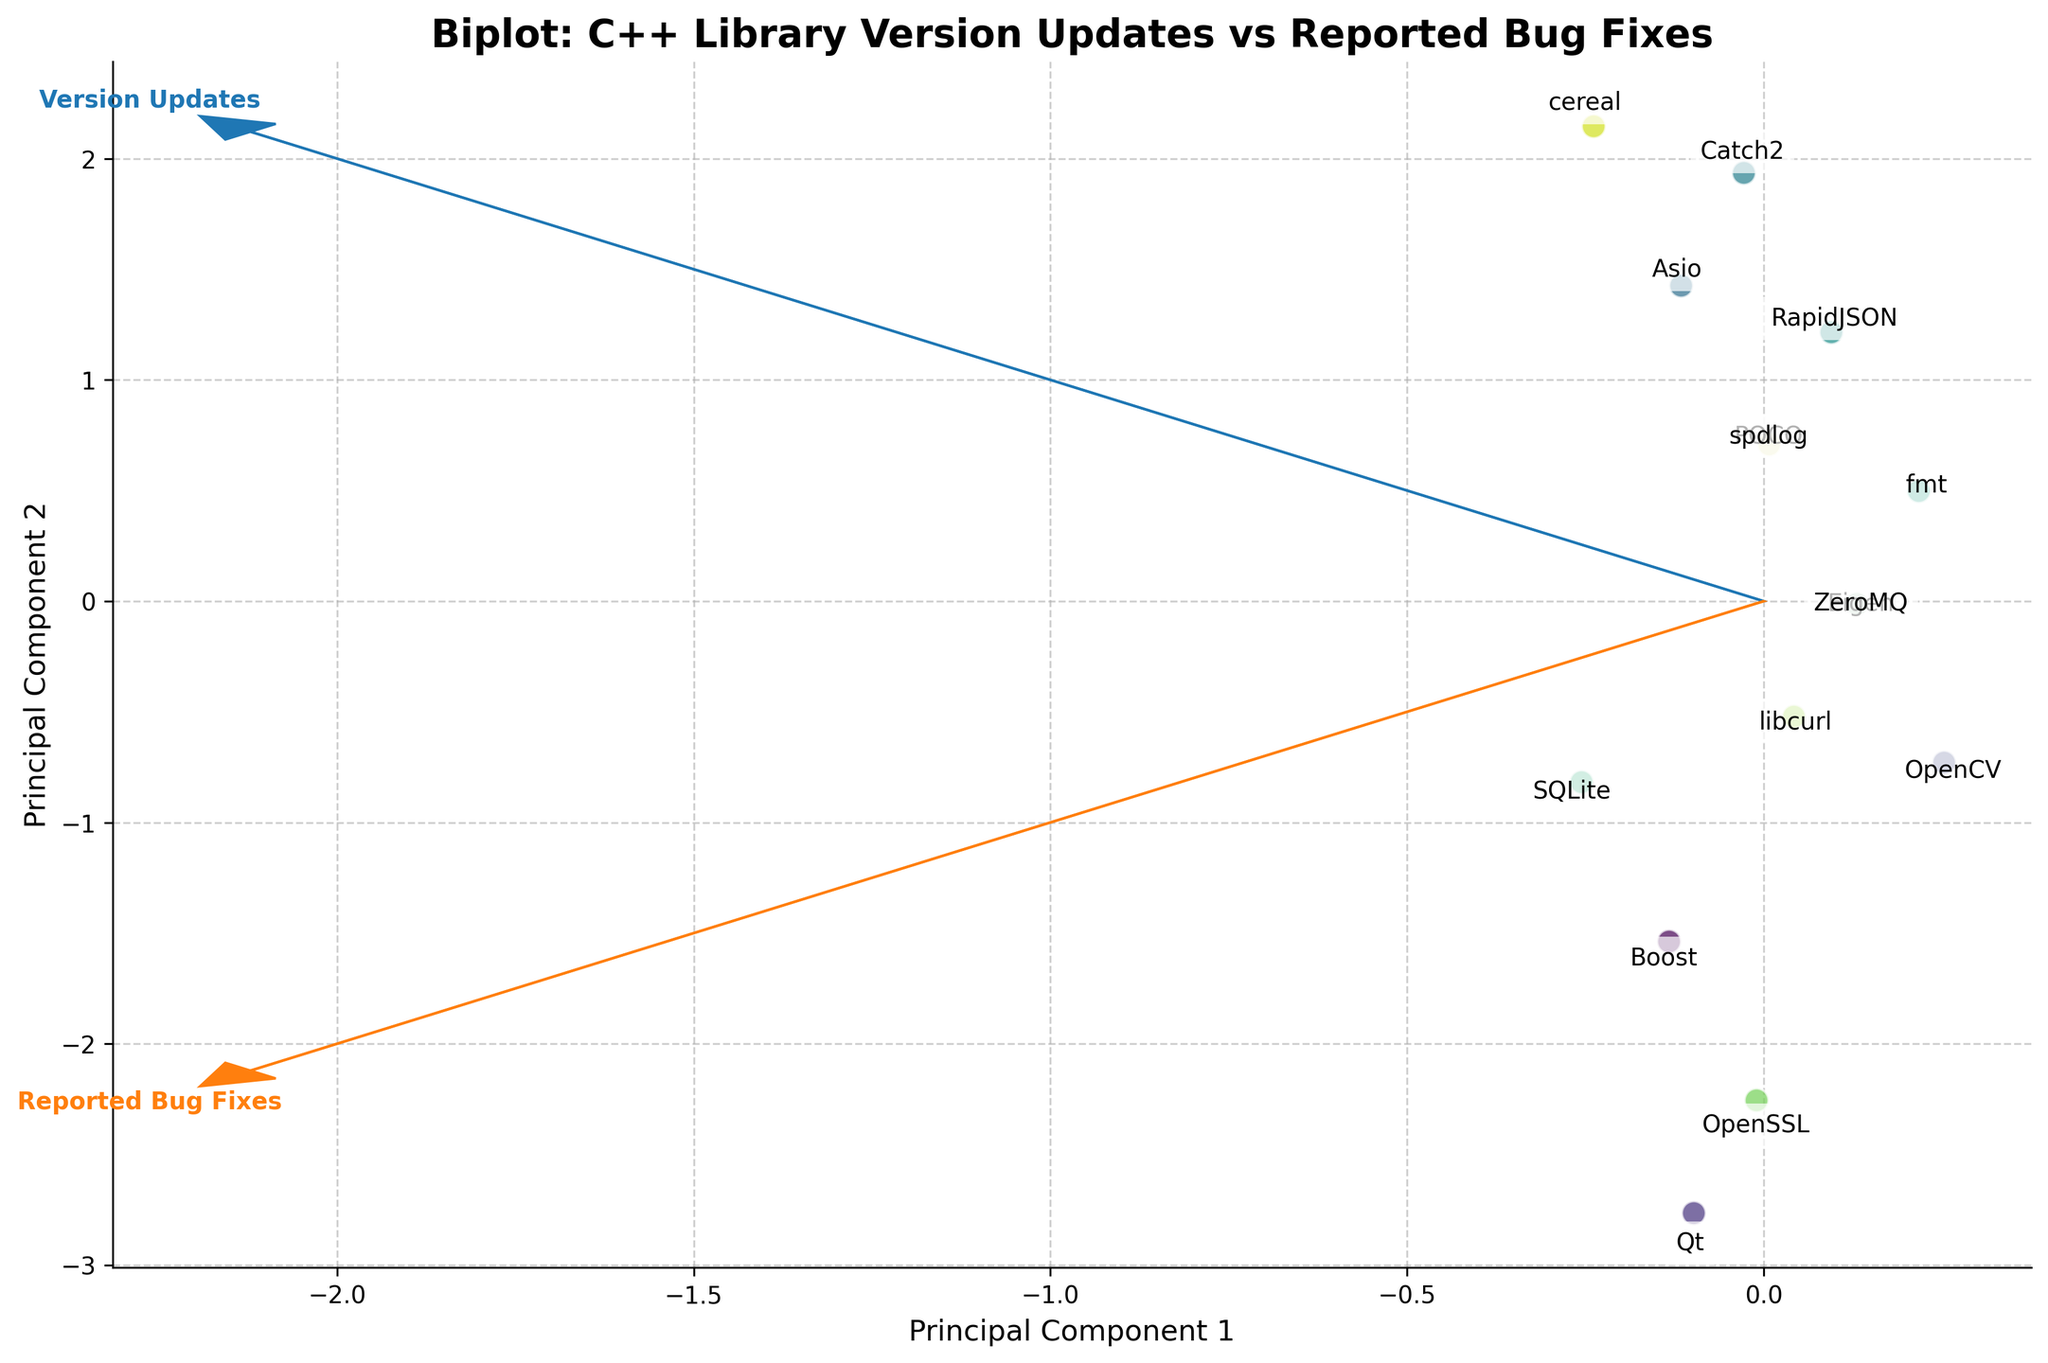What's the title of the plot? The title is usually located at the top of the plot in a larger or bolder font.
Answer: Biplot: C++ Library Version Updates vs Reported Bug Fixes How many libraries are shown in the plot? Each library is represented by a point with a label next to it. Count the labels to find the number of libraries.
Answer: 15 Which library has the highest 'Reported Bug Fixes'? Locate the point farthest along the axis corresponding to 'Reported Bug Fixes'. This library's label will be nearby.
Answer: Qt How are 'Version Updates' and 'Reported Bug Fixes' related in general? Observe the directions of the vectors (arrows). If they point similarly, they indicate a positive correlation; oppositely, a negative correlation.
Answer: Positively correlated Which principal component explains more variance in the data? The length of the vectors (arrows) on the plot indicates the variance explained by each principal component. The longer vector represents the principal component that explains more variance.
Answer: Principal Component 1 Which library has the smallest principal component 1 value? Identify the point farthest in the negative direction along the principal component 1 axis.
Answer: Catch2 Between OpenCV and POCO, which one has more 'Version Updates'? Compare the positions along the 'Version Updates' vector. Locate both points, and the one further along the vector indicates more version updates.
Answer: OpenCV Are 'libcurl' and 'OpenSSL' close to each other in the plot? Check the distance between the points representing 'libcurl' and 'OpenSSL'.
Answer: Yes Which principal component axis explains most of the variation in the 'Reported Bug Fixes'? Check the orientation and length of the 'Reported Bug Fixes' vector in relation to the principal component axes.
Answer: Principal Component 2 What is the general trend shown by the libraries in terms of 'Version Updates' and 'Reported Bug Fixes'? Examine the overall distribution and direction of points along the vectors for 'Version Updates' and 'Reported Bug Fixes'.
Answer: Libraries with more version updates tend to have more reported bug fixes 